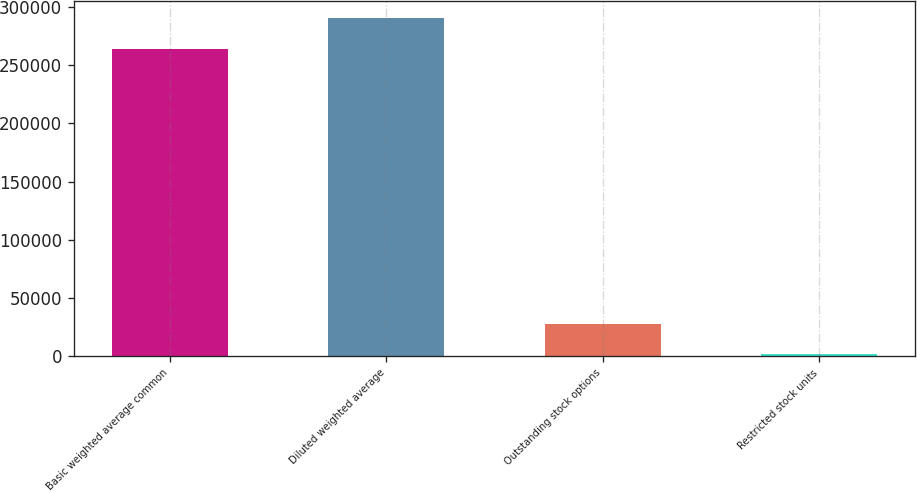Convert chart to OTSL. <chart><loc_0><loc_0><loc_500><loc_500><bar_chart><fcel>Basic weighted average common<fcel>Diluted weighted average<fcel>Outstanding stock options<fcel>Restricted stock units<nl><fcel>264041<fcel>290307<fcel>27644.3<fcel>1378<nl></chart> 